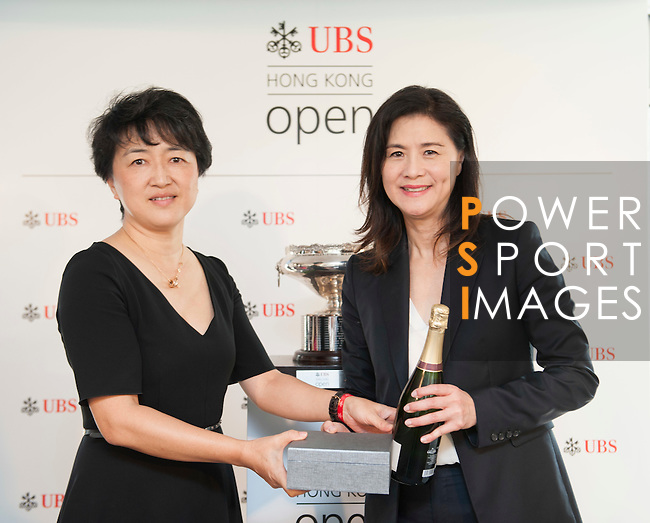Tell me more about the setting of this photograph. The photograph is set against a backdrop featuring the logos 'Hong Kong Open UBS' and 'POWER SPORT IMAGES', which hints at the affiliation with a sporting event, possibly related to golf considering the prominence of the event. The backdrop is promotional in nature, suggesting the photo might have been taken during a ceremony or special occasion connected to the event. 